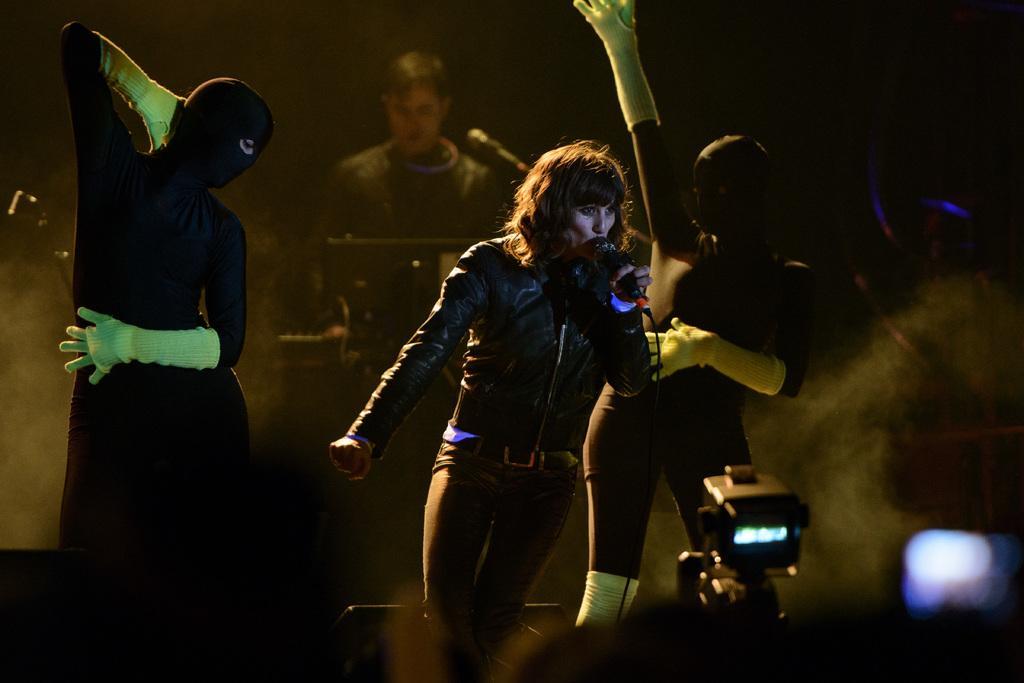Describe this image in one or two sentences. In this image, we can see two people dancing, there is a woman singing into the microphone, we can see some lights, in the background we can see a man sitting and playing a musical instrument. 